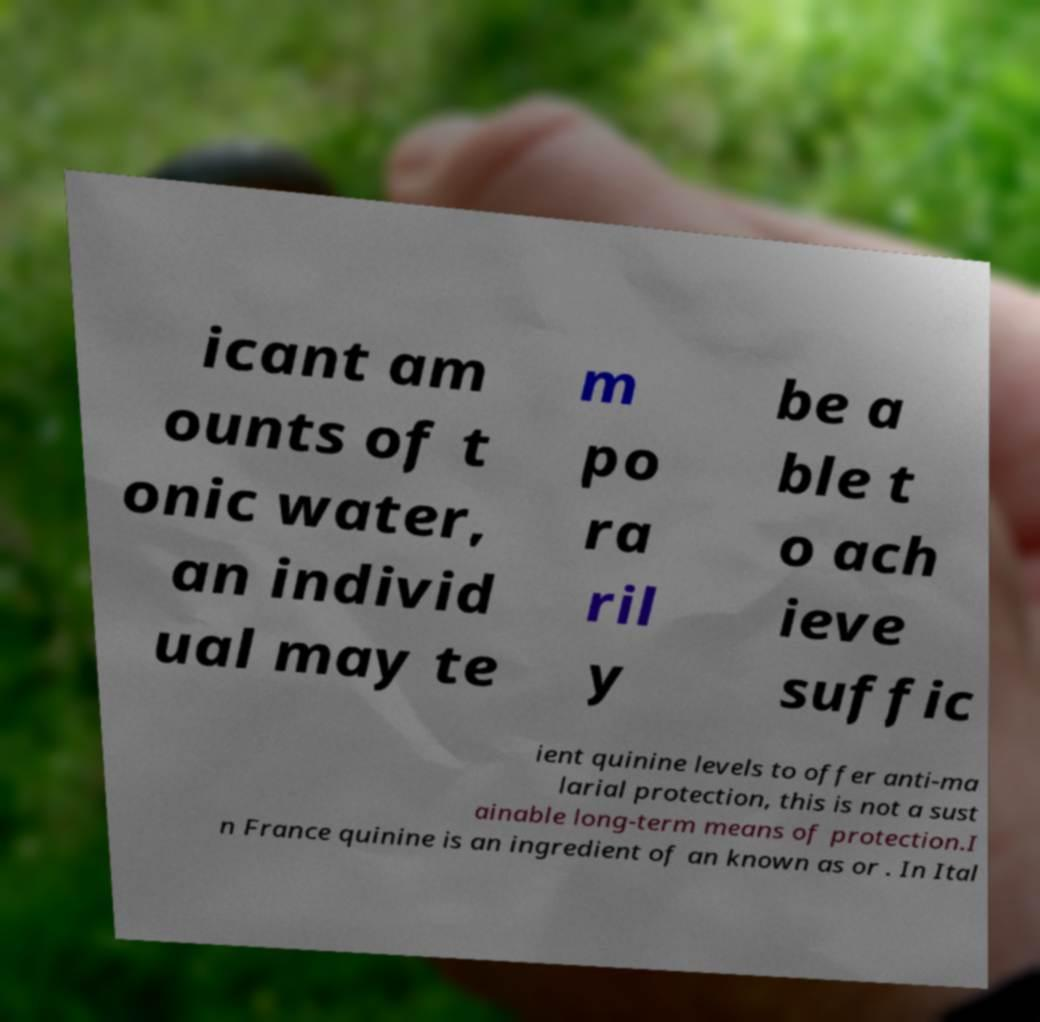I need the written content from this picture converted into text. Can you do that? icant am ounts of t onic water, an individ ual may te m po ra ril y be a ble t o ach ieve suffic ient quinine levels to offer anti-ma larial protection, this is not a sust ainable long-term means of protection.I n France quinine is an ingredient of an known as or . In Ital 